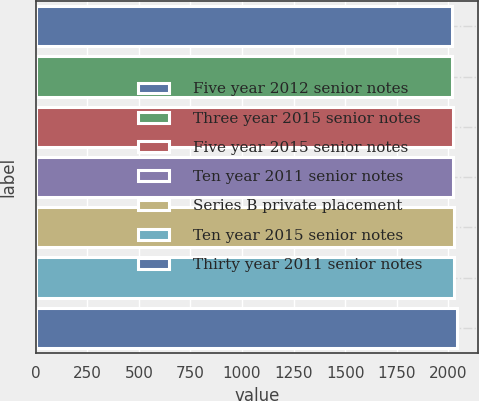Convert chart. <chart><loc_0><loc_0><loc_500><loc_500><bar_chart><fcel>Five year 2012 senior notes<fcel>Three year 2015 senior notes<fcel>Five year 2015 senior notes<fcel>Ten year 2011 senior notes<fcel>Series B private placement<fcel>Ten year 2015 senior notes<fcel>Thirty year 2011 senior notes<nl><fcel>2017<fcel>2019.4<fcel>2021.8<fcel>2024.2<fcel>2026.6<fcel>2029<fcel>2041<nl></chart> 